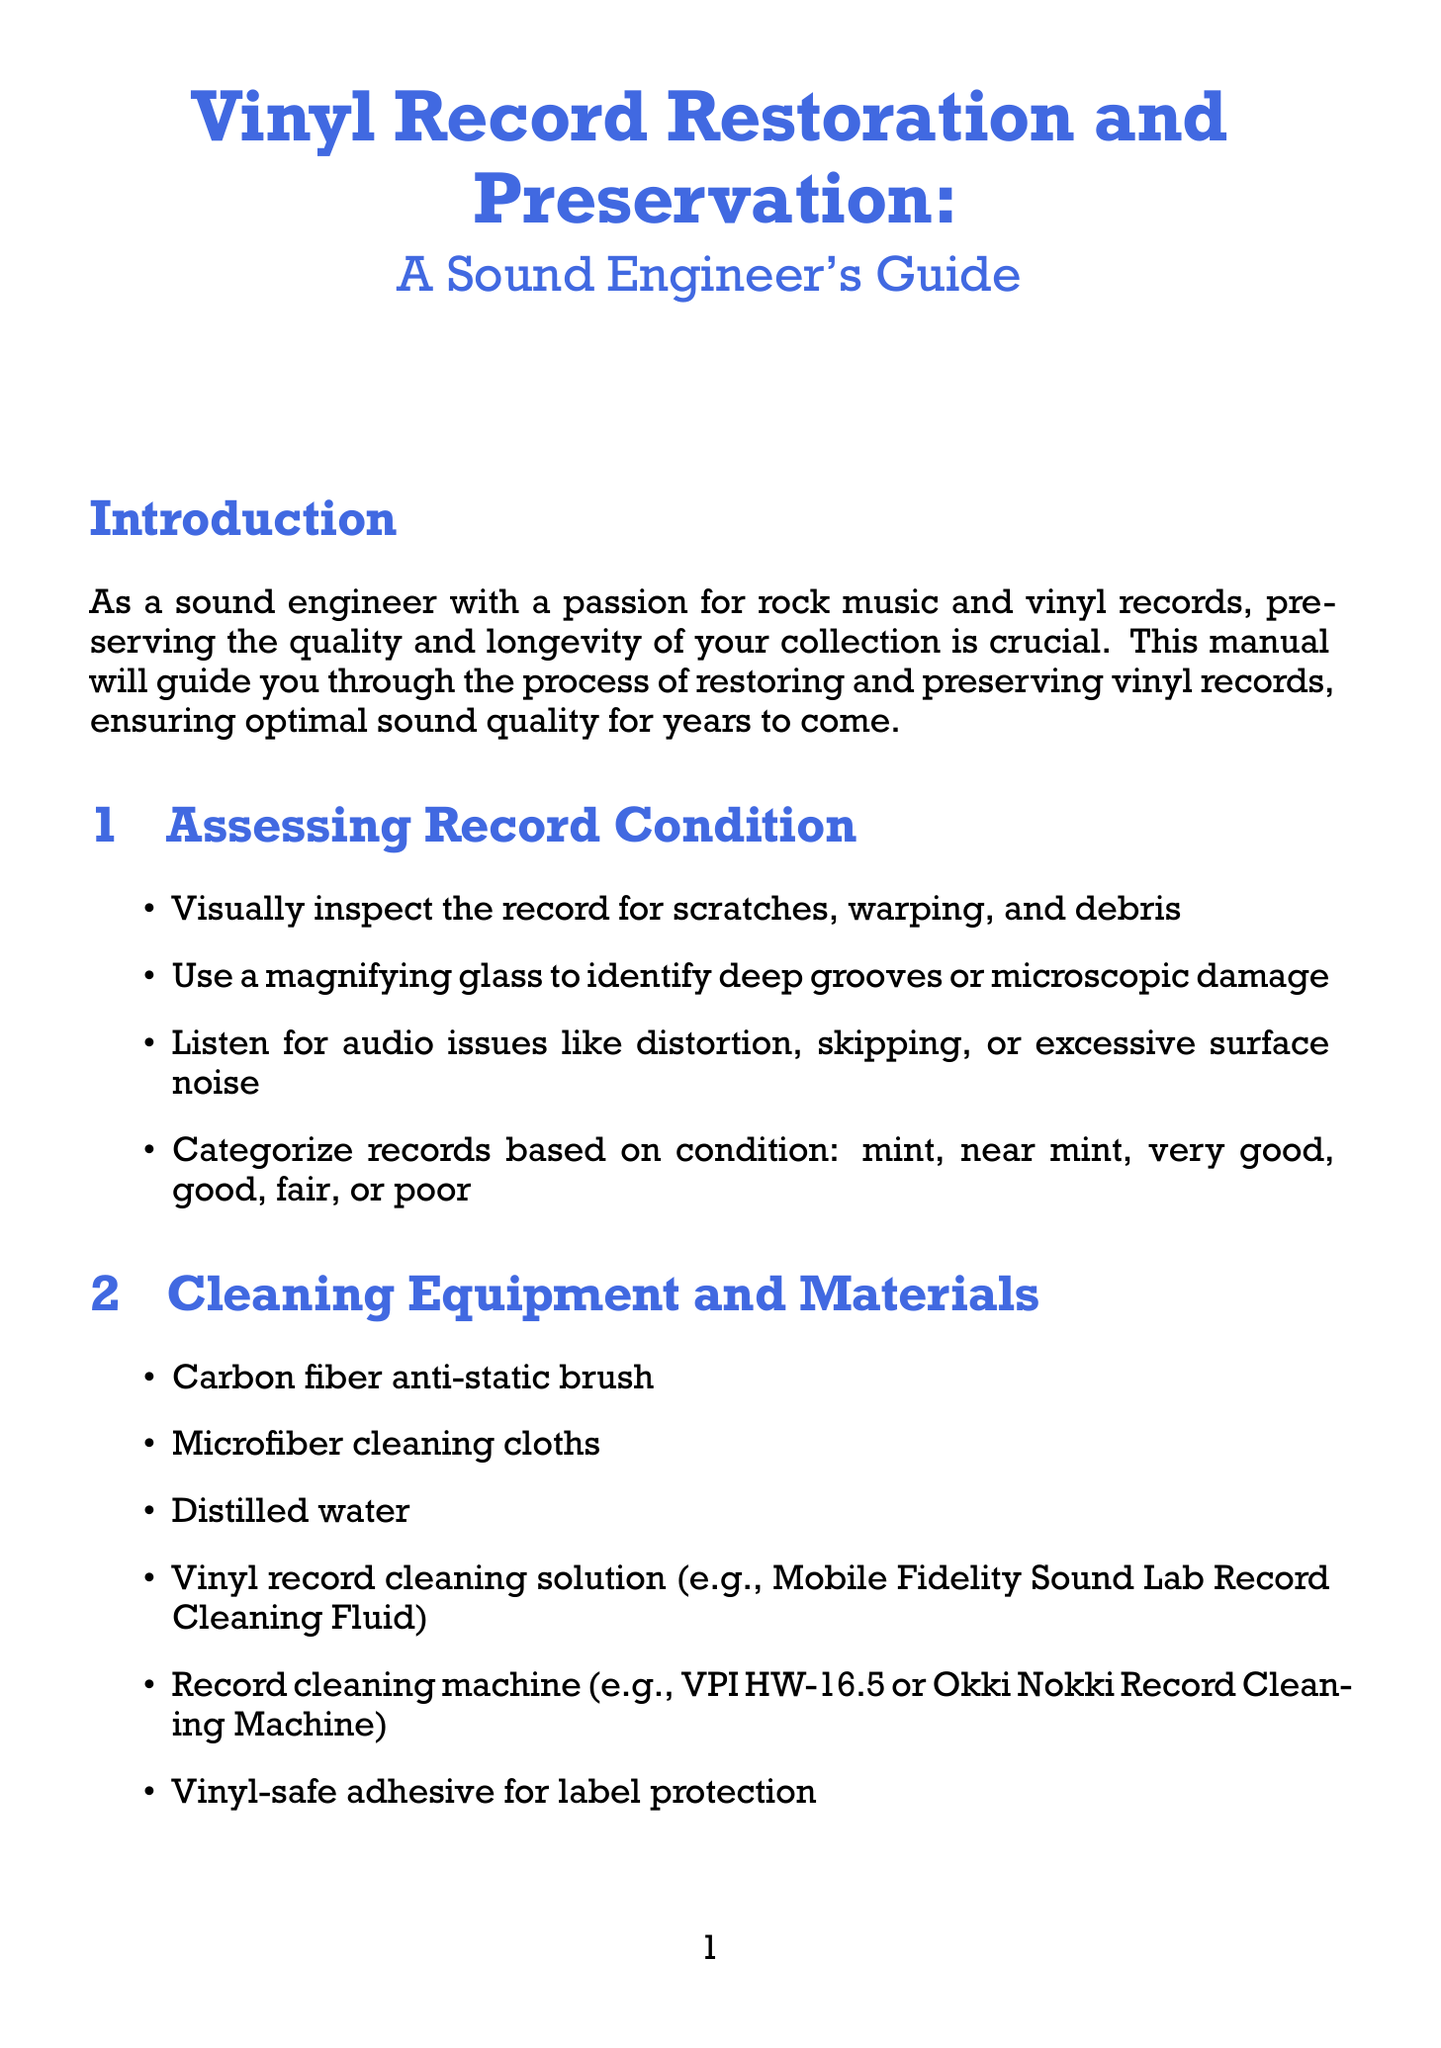What is the title of the manual? The title is provided in the first section of the document.
Answer: Vinyl Record Restoration and Preservation: A Sound Engineer's Guide What is the first step in assessing record condition? The steps for assessing record condition are listed in the second section.
Answer: Visually inspect the record for scratches, warping, and debris How many categories are used for categorizing records? The document outlines the different categories for record condition.
Answer: Six Which tool is recommended for cleaning records? The document specifies various items required for cleaning records.
Answer: Carbon fiber anti-static brush What type of adhesive should be used to protect the label? The cleaning process details what adhesive to use during deep cleaning.
Answer: Vinyl-safe adhesive What should you do to handle records properly? The guidelines in the section about proper storage and handling highlight best practices.
Answer: Handle records by the edges and label area only Which vinyl repair kit is mentioned for minor scratches? The document mentions specific tools for addressing physical damage.
Answer: Groovmaster Record Repair Kit What should be done every 1000-2000 hours of play? The turntable maintenance section discusses the frequency for stylus replacement.
Answer: Replace the stylus What audio software is suggested for recording digitized vinyl? The digitizing process provides a list of tools for this task.
Answer: Pro Tools or Audacity 